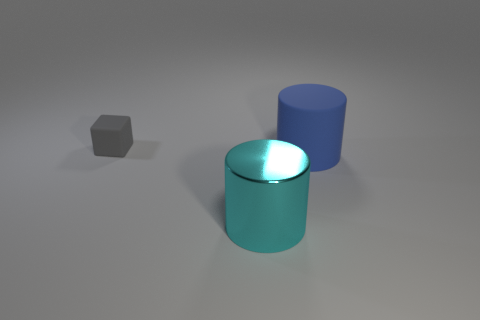Add 3 large purple cylinders. How many objects exist? 6 Subtract all cylinders. How many objects are left? 1 Subtract 0 blue cubes. How many objects are left? 3 Subtract all yellow rubber spheres. Subtract all metal cylinders. How many objects are left? 2 Add 1 small gray matte things. How many small gray matte things are left? 2 Add 1 tiny gray rubber cubes. How many tiny gray rubber cubes exist? 2 